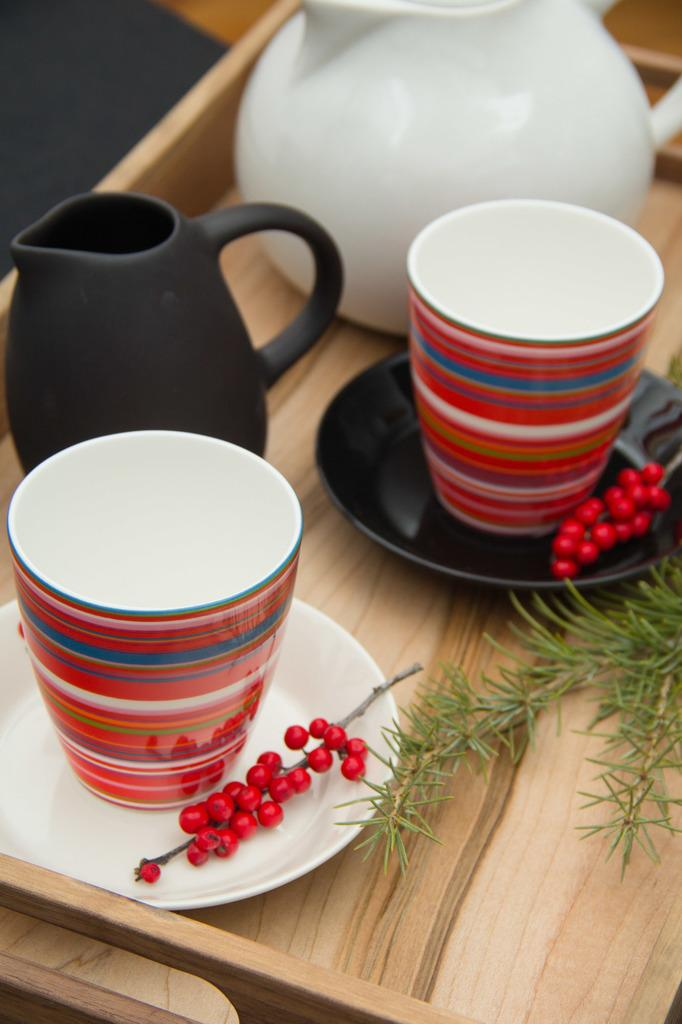What type of dishware can be seen in the image? There are cups and saucers in the image. What is placed on the saucers? There is a bunch of red-currants on the saucer plates. What type of plant is visible in the image? There is a green plant in the image. What kitchen appliances can be seen in the image? There are kettles in the image. What surface is visible in the image? The wooden surface is present in the image. What type of silverware is being used by the boy in the image? There is no boy or silverware present in the image. How does the chin of the person in the image look while eating the red-currants? There is no person or chin visible in the image. 